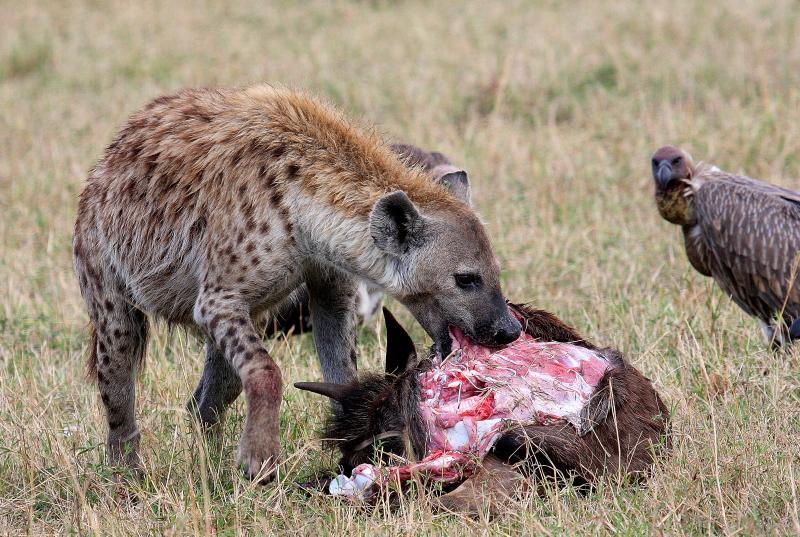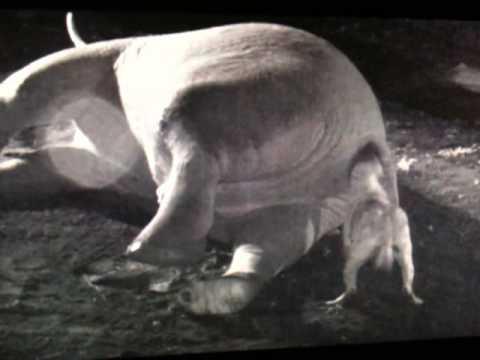The first image is the image on the left, the second image is the image on the right. For the images displayed, is the sentence "The animal in the image on the right is carrying an elephant foot." factually correct? Answer yes or no. No. 